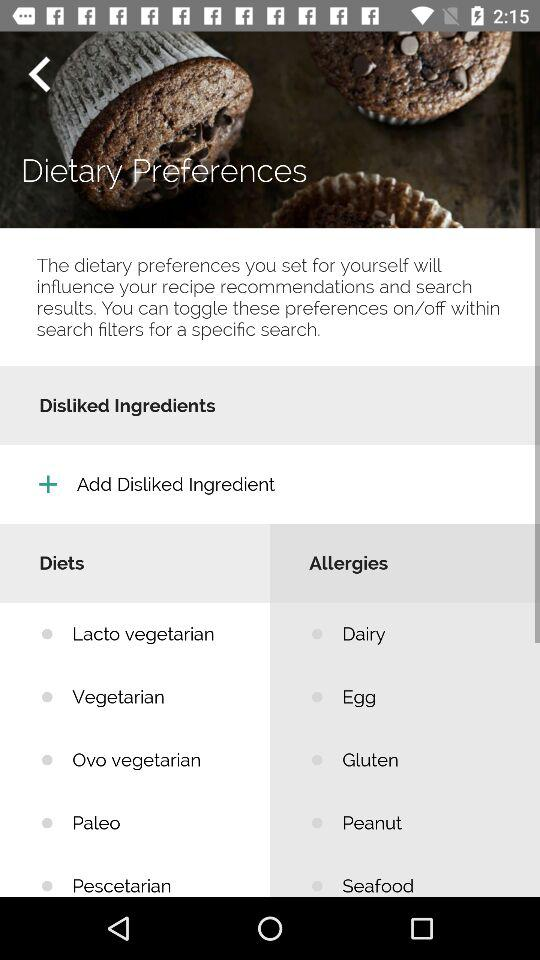Which are the options for diet products? The options are "Lacto vegetarian", "Vegetarian", "Ovo vegetarian", "Paleo" and "Pescetarian". 